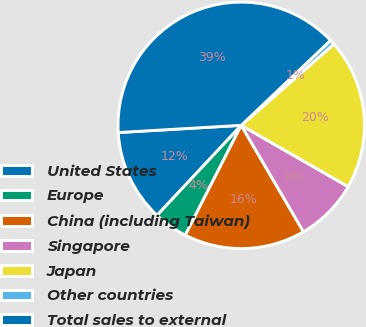Convert chart to OTSL. <chart><loc_0><loc_0><loc_500><loc_500><pie_chart><fcel>United States<fcel>Europe<fcel>China (including Taiwan)<fcel>Singapore<fcel>Japan<fcel>Other countries<fcel>Total sales to external<nl><fcel>12.1%<fcel>4.47%<fcel>15.92%<fcel>8.29%<fcel>19.74%<fcel>0.65%<fcel>38.82%<nl></chart> 